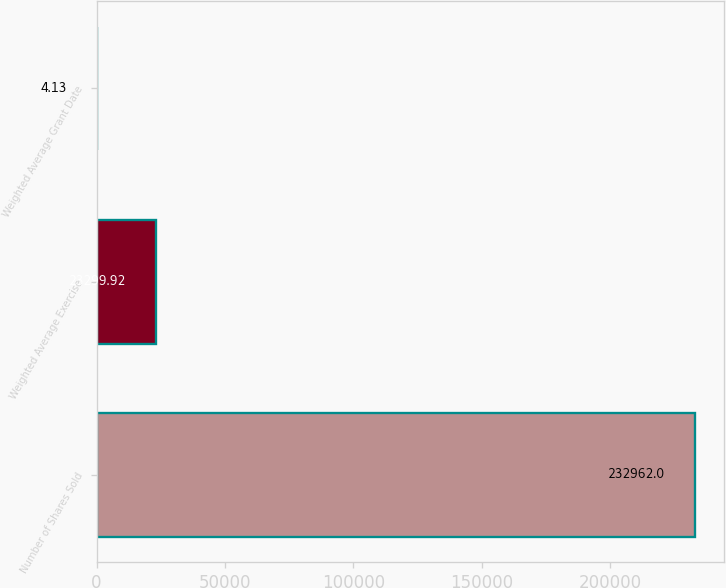Convert chart to OTSL. <chart><loc_0><loc_0><loc_500><loc_500><bar_chart><fcel>Number of Shares Sold<fcel>Weighted Average Exercise<fcel>Weighted Average Grant Date<nl><fcel>232962<fcel>23299.9<fcel>4.13<nl></chart> 